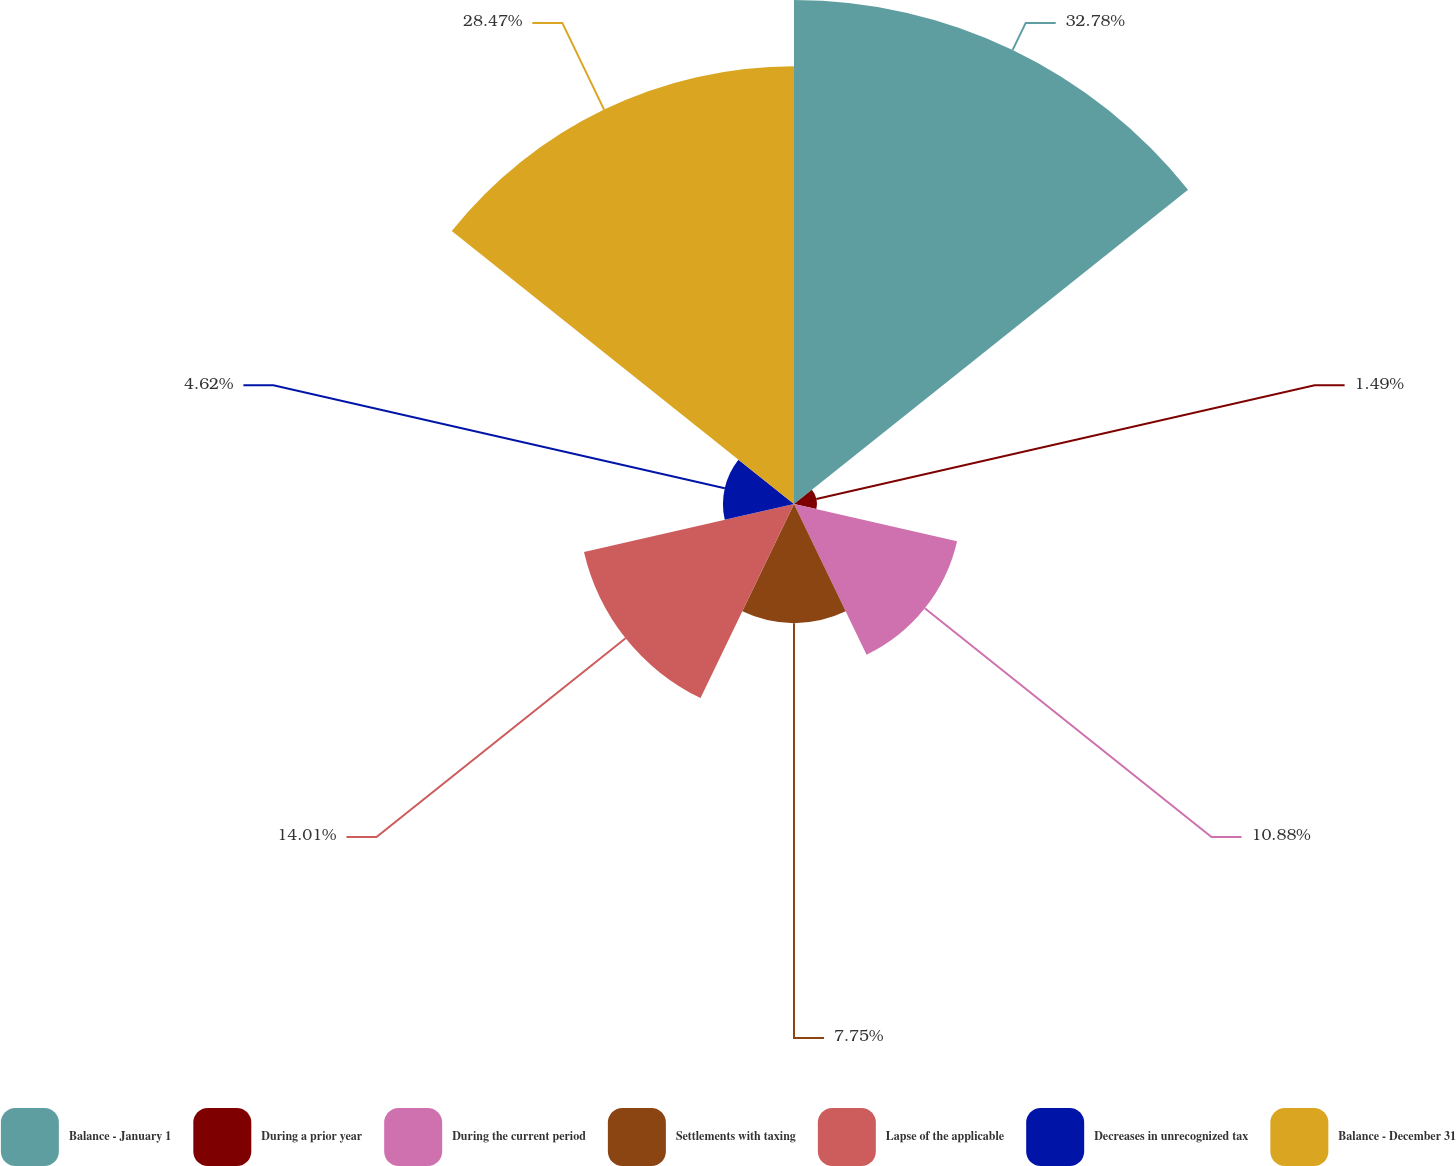Convert chart. <chart><loc_0><loc_0><loc_500><loc_500><pie_chart><fcel>Balance - January 1<fcel>During a prior year<fcel>During the current period<fcel>Settlements with taxing<fcel>Lapse of the applicable<fcel>Decreases in unrecognized tax<fcel>Balance - December 31<nl><fcel>32.78%<fcel>1.49%<fcel>10.88%<fcel>7.75%<fcel>14.01%<fcel>4.62%<fcel>28.47%<nl></chart> 